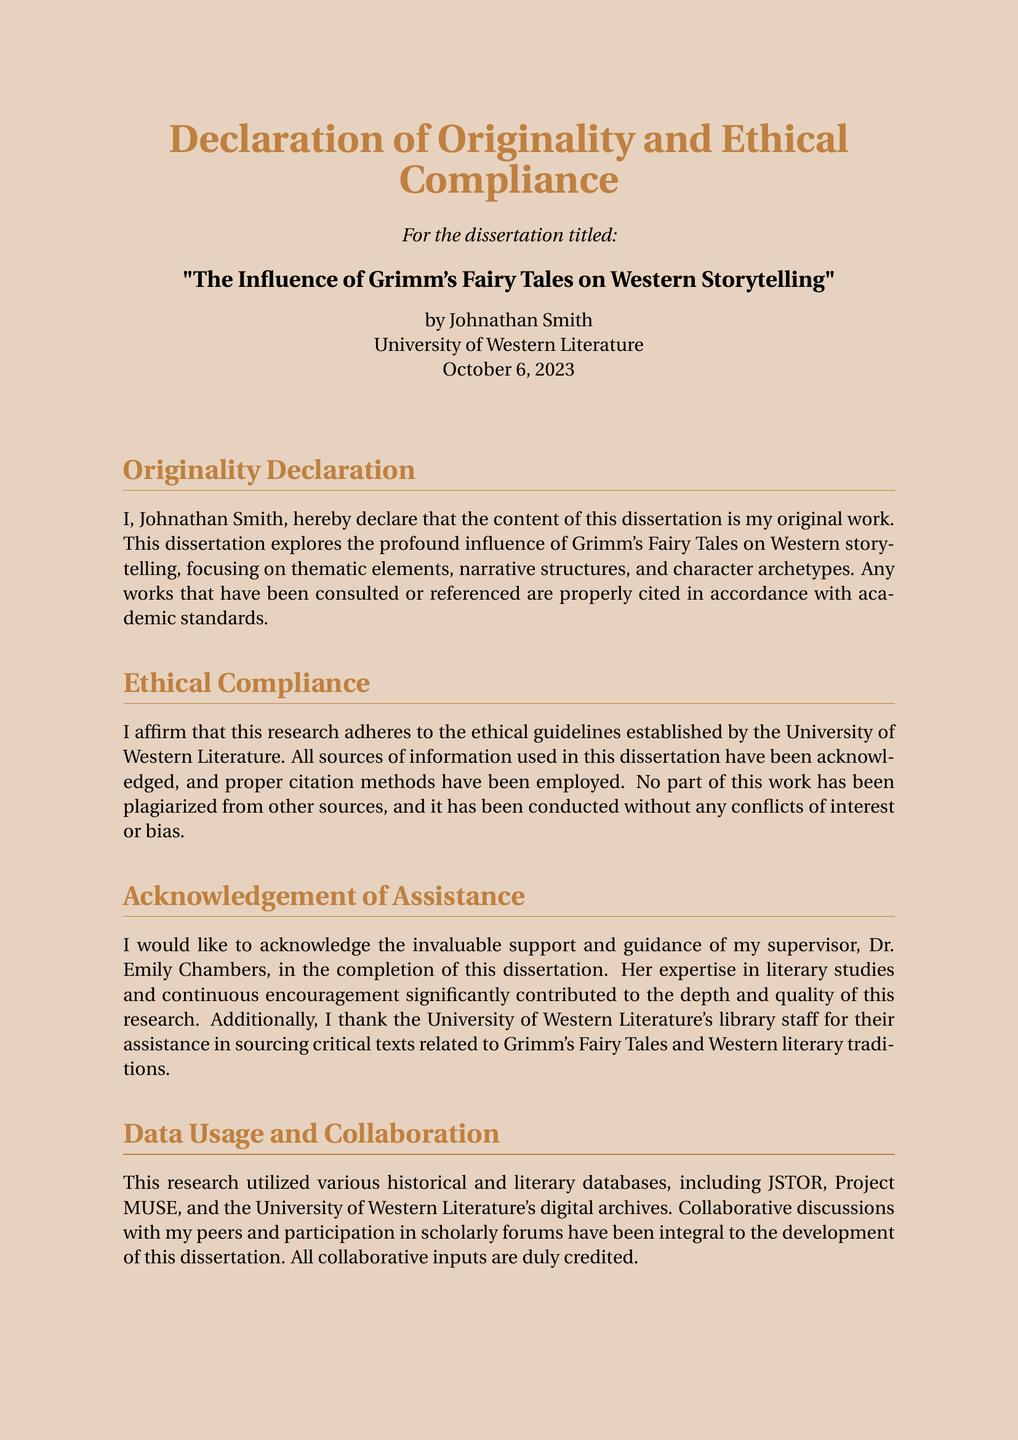What is the title of the dissertation? The title of the dissertation is specifically stated in the document.
Answer: The Influence of Grimm's Fairy Tales on Western Storytelling Who is the author of the dissertation? The document explicitly states the name of the author.
Answer: Johnathan Smith What is the date of the declaration? The date of the declaration is mentioned at the bottom of the document.
Answer: October 6, 2023 What university is associated with the dissertation? The university name is noted in the header section of the document.
Answer: University of Western Literature Who is acknowledged for their assistance in the dissertation? The document mentions a specific individual who provided support and guidance.
Answer: Dr. Emily Chambers Which databases were utilized for this research? The document lists the databases that were used in the research section.
Answer: JSTOR, Project MUSE, and University of Western Literature's digital archives What aspect of Grimm's Fairy Tales is explored in this dissertation? The document outlines the specific focus areas of the research on Grimm's Fairy Tales.
Answer: Thematic elements, narrative structures, and character archetypes Is there any mention of ethical compliance in the dissertation? The document includes a section specifically addressing ethical compliance.
Answer: Yes What is the color scheme of the document? The document describes its background color in the initial settings.
Answer: Fairytale 